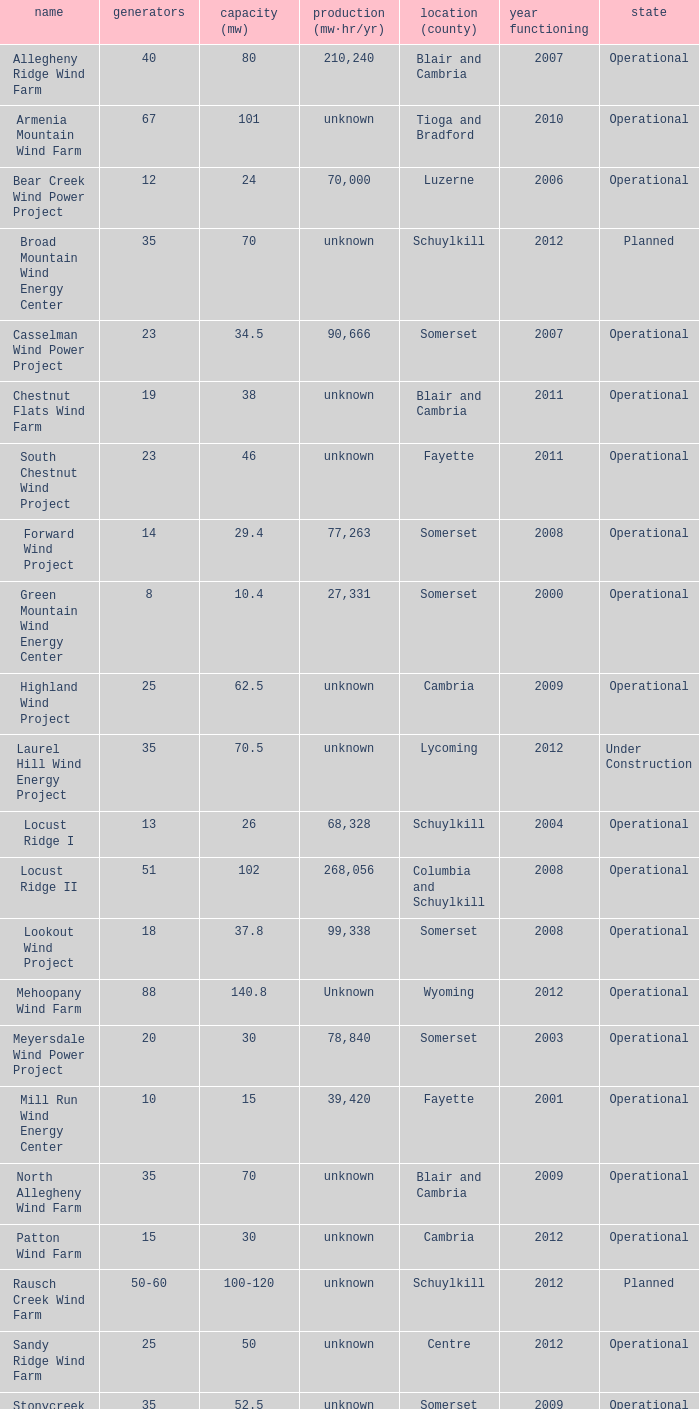What all capacities have turbines between 50-60? 100-120. 